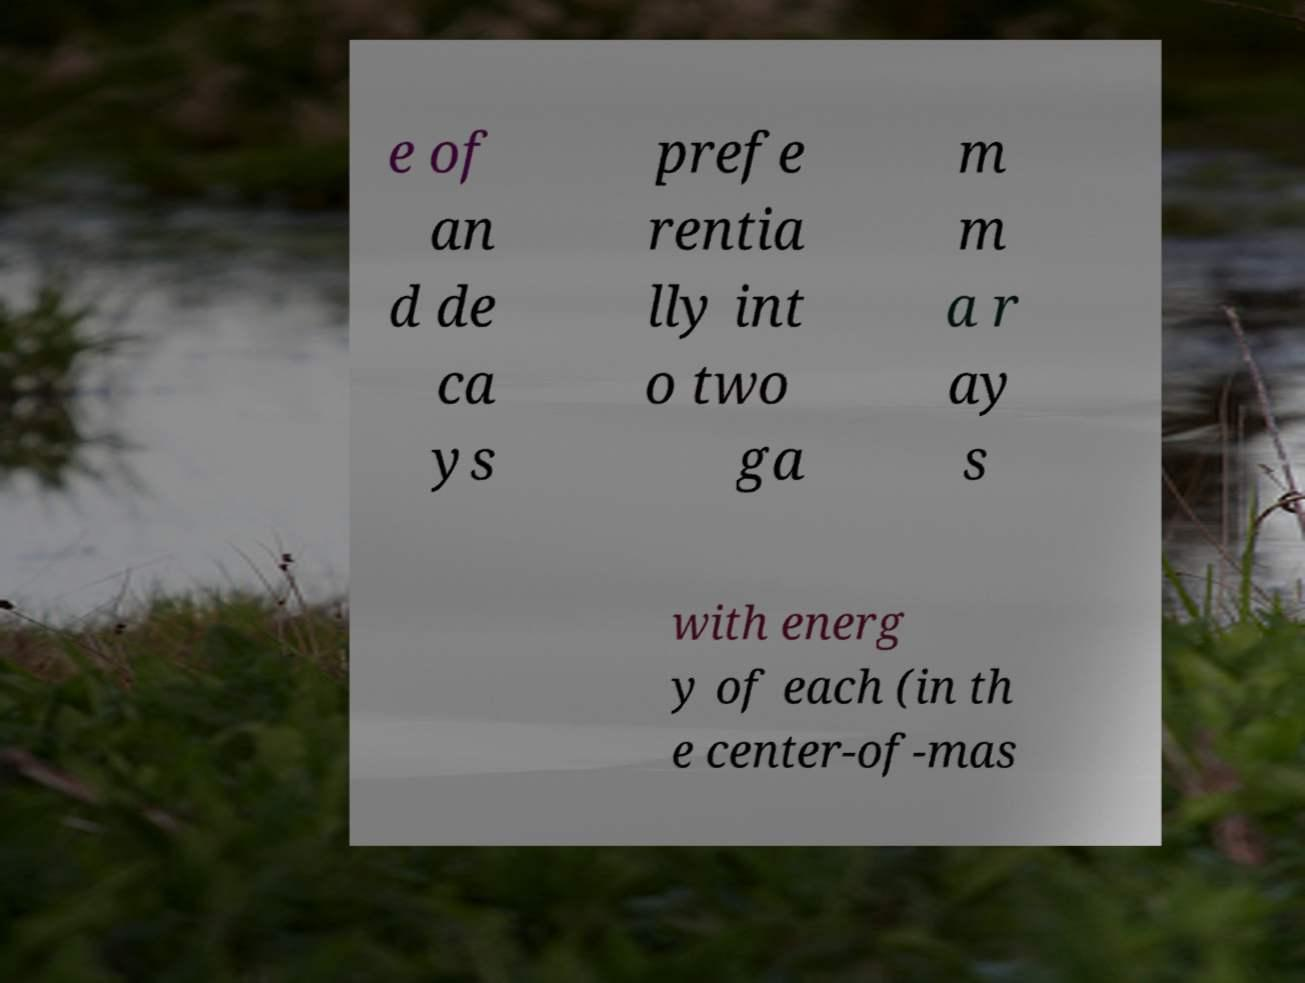Could you extract and type out the text from this image? e of an d de ca ys prefe rentia lly int o two ga m m a r ay s with energ y of each (in th e center-of-mas 